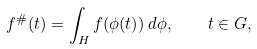<formula> <loc_0><loc_0><loc_500><loc_500>f ^ { \# } ( t ) = \int _ { H } f ( \phi ( t ) ) \, d \phi , \quad t \in G ,</formula> 